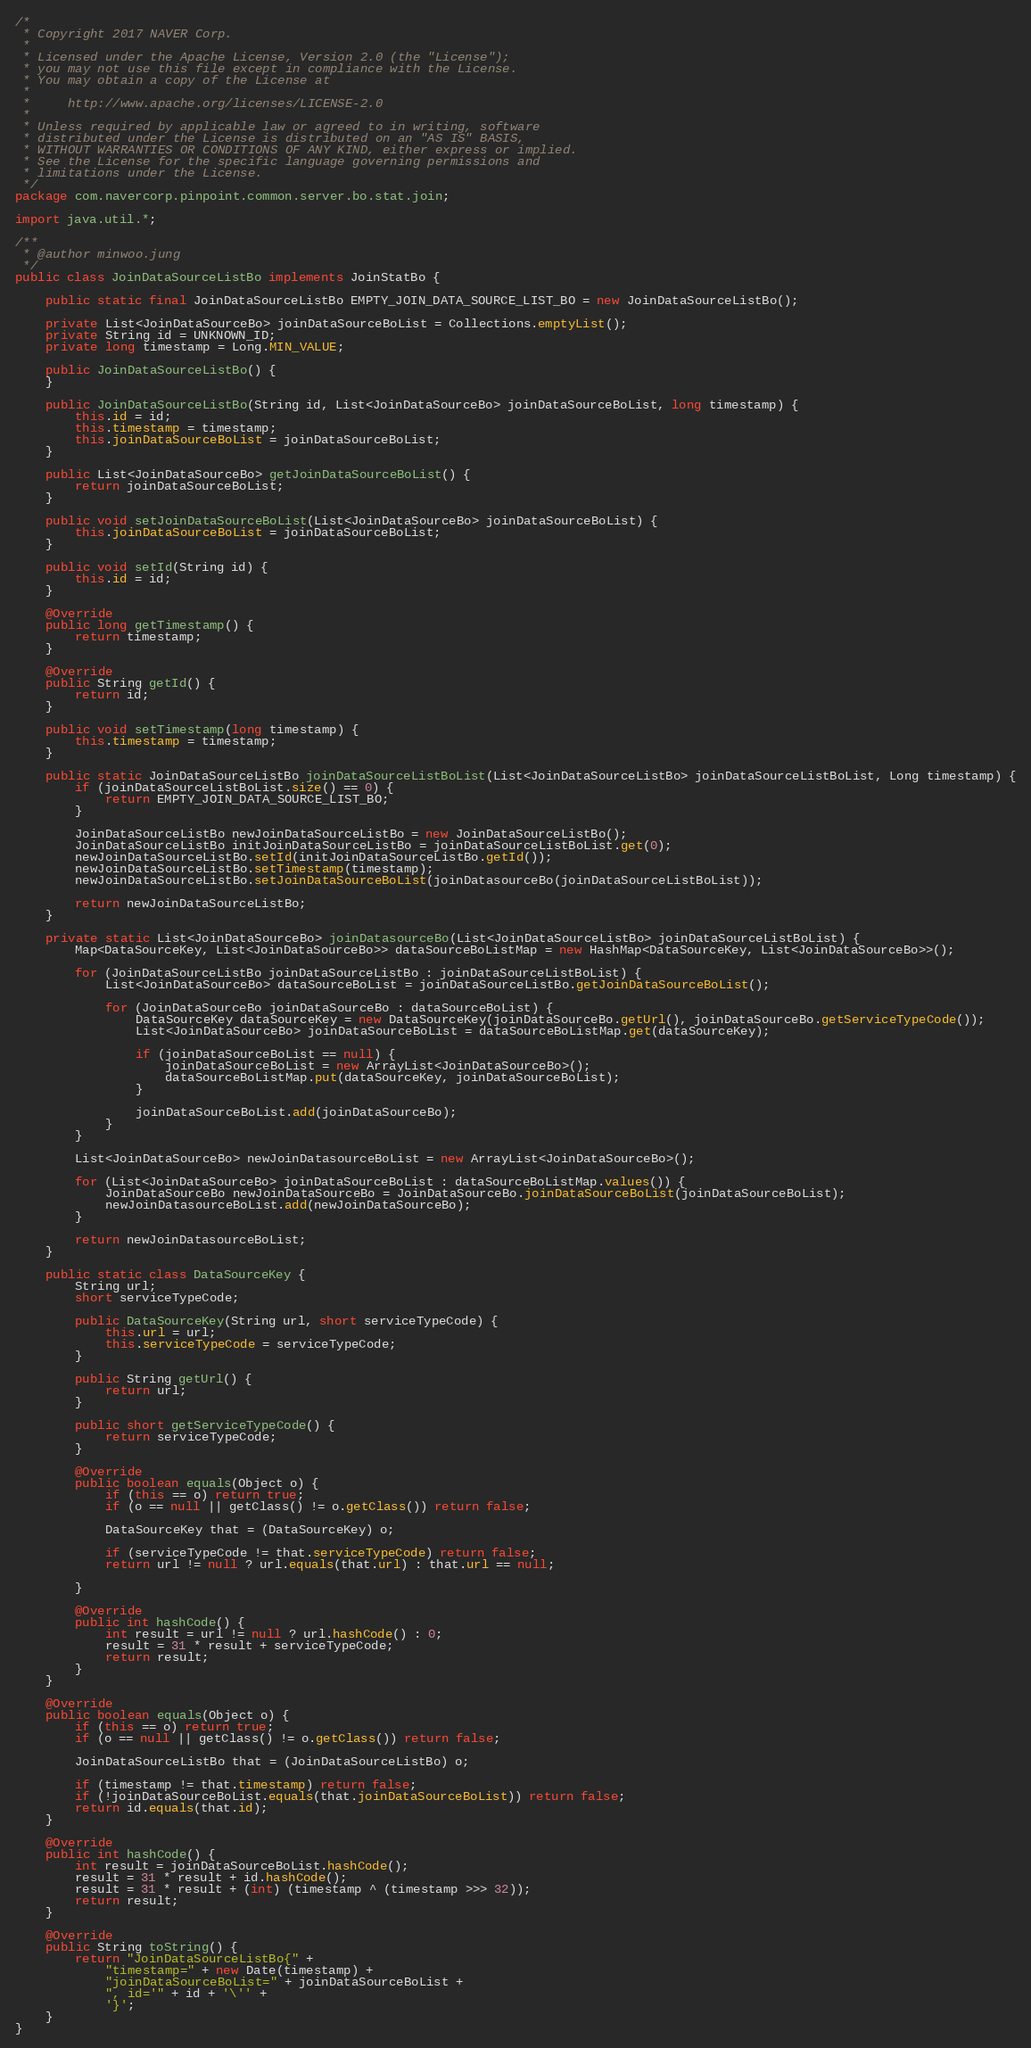Convert code to text. <code><loc_0><loc_0><loc_500><loc_500><_Java_>/*
 * Copyright 2017 NAVER Corp.
 *
 * Licensed under the Apache License, Version 2.0 (the "License");
 * you may not use this file except in compliance with the License.
 * You may obtain a copy of the License at
 *
 *     http://www.apache.org/licenses/LICENSE-2.0
 *
 * Unless required by applicable law or agreed to in writing, software
 * distributed under the License is distributed on an "AS IS" BASIS,
 * WITHOUT WARRANTIES OR CONDITIONS OF ANY KIND, either express or implied.
 * See the License for the specific language governing permissions and
 * limitations under the License.
 */
package com.navercorp.pinpoint.common.server.bo.stat.join;

import java.util.*;

/**
 * @author minwoo.jung
 */
public class JoinDataSourceListBo implements JoinStatBo {

    public static final JoinDataSourceListBo EMPTY_JOIN_DATA_SOURCE_LIST_BO = new JoinDataSourceListBo();

    private List<JoinDataSourceBo> joinDataSourceBoList = Collections.emptyList();
    private String id = UNKNOWN_ID;
    private long timestamp = Long.MIN_VALUE;

    public JoinDataSourceListBo() {
    }

    public JoinDataSourceListBo(String id, List<JoinDataSourceBo> joinDataSourceBoList, long timestamp) {
        this.id = id;
        this.timestamp = timestamp;
        this.joinDataSourceBoList = joinDataSourceBoList;
    }

    public List<JoinDataSourceBo> getJoinDataSourceBoList() {
        return joinDataSourceBoList;
    }

    public void setJoinDataSourceBoList(List<JoinDataSourceBo> joinDataSourceBoList) {
        this.joinDataSourceBoList = joinDataSourceBoList;
    }

    public void setId(String id) {
        this.id = id;
    }

    @Override
    public long getTimestamp() {
        return timestamp;
    }

    @Override
    public String getId() {
        return id;
    }

    public void setTimestamp(long timestamp) {
        this.timestamp = timestamp;
    }

    public static JoinDataSourceListBo joinDataSourceListBoList(List<JoinDataSourceListBo> joinDataSourceListBoList, Long timestamp) {
        if (joinDataSourceListBoList.size() == 0) {
            return EMPTY_JOIN_DATA_SOURCE_LIST_BO;
        }

        JoinDataSourceListBo newJoinDataSourceListBo = new JoinDataSourceListBo();
        JoinDataSourceListBo initJoinDataSourceListBo = joinDataSourceListBoList.get(0);
        newJoinDataSourceListBo.setId(initJoinDataSourceListBo.getId());
        newJoinDataSourceListBo.setTimestamp(timestamp);
        newJoinDataSourceListBo.setJoinDataSourceBoList(joinDatasourceBo(joinDataSourceListBoList));

        return newJoinDataSourceListBo;
    }

    private static List<JoinDataSourceBo> joinDatasourceBo(List<JoinDataSourceListBo> joinDataSourceListBoList) {
        Map<DataSourceKey, List<JoinDataSourceBo>> dataSourceBoListMap = new HashMap<DataSourceKey, List<JoinDataSourceBo>>();

        for (JoinDataSourceListBo joinDataSourceListBo : joinDataSourceListBoList) {
            List<JoinDataSourceBo> dataSourceBoList = joinDataSourceListBo.getJoinDataSourceBoList();

            for (JoinDataSourceBo joinDataSourceBo : dataSourceBoList) {
                DataSourceKey dataSourceKey = new DataSourceKey(joinDataSourceBo.getUrl(), joinDataSourceBo.getServiceTypeCode());
                List<JoinDataSourceBo> joinDataSourceBoList = dataSourceBoListMap.get(dataSourceKey);

                if (joinDataSourceBoList == null) {
                    joinDataSourceBoList = new ArrayList<JoinDataSourceBo>();
                    dataSourceBoListMap.put(dataSourceKey, joinDataSourceBoList);
                }

                joinDataSourceBoList.add(joinDataSourceBo);
            }
        }

        List<JoinDataSourceBo> newJoinDatasourceBoList = new ArrayList<JoinDataSourceBo>();

        for (List<JoinDataSourceBo> joinDataSourceBoList : dataSourceBoListMap.values()) {
            JoinDataSourceBo newJoinDataSourceBo = JoinDataSourceBo.joinDataSourceBoList(joinDataSourceBoList);
            newJoinDatasourceBoList.add(newJoinDataSourceBo);
        }

        return newJoinDatasourceBoList;
    }

    public static class DataSourceKey {
        String url;
        short serviceTypeCode;

        public DataSourceKey(String url, short serviceTypeCode) {
            this.url = url;
            this.serviceTypeCode = serviceTypeCode;
        }

        public String getUrl() {
            return url;
        }

        public short getServiceTypeCode() {
            return serviceTypeCode;
        }

        @Override
        public boolean equals(Object o) {
            if (this == o) return true;
            if (o == null || getClass() != o.getClass()) return false;

            DataSourceKey that = (DataSourceKey) o;

            if (serviceTypeCode != that.serviceTypeCode) return false;
            return url != null ? url.equals(that.url) : that.url == null;

        }

        @Override
        public int hashCode() {
            int result = url != null ? url.hashCode() : 0;
            result = 31 * result + serviceTypeCode;
            return result;
        }
    }

    @Override
    public boolean equals(Object o) {
        if (this == o) return true;
        if (o == null || getClass() != o.getClass()) return false;

        JoinDataSourceListBo that = (JoinDataSourceListBo) o;

        if (timestamp != that.timestamp) return false;
        if (!joinDataSourceBoList.equals(that.joinDataSourceBoList)) return false;
        return id.equals(that.id);
    }

    @Override
    public int hashCode() {
        int result = joinDataSourceBoList.hashCode();
        result = 31 * result + id.hashCode();
        result = 31 * result + (int) (timestamp ^ (timestamp >>> 32));
        return result;
    }

    @Override
    public String toString() {
        return "JoinDataSourceListBo{" +
            "timestamp=" + new Date(timestamp) +
            "joinDataSourceBoList=" + joinDataSourceBoList +
            ", id='" + id + '\'' +
            '}';
    }
}
</code> 